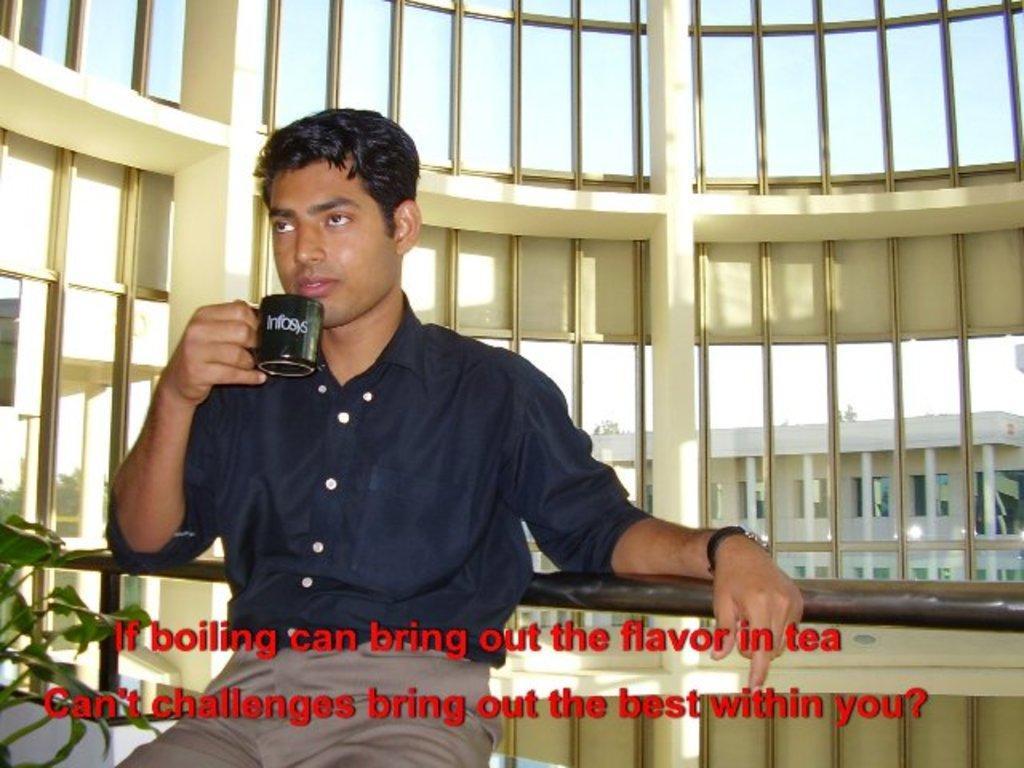Please provide a concise description of this image. In the foreground of the picture we can see a person holding a cup and there are railing, plant and text. In the background we can see a building, wall with glass windows, outside the windows there are trees and building. At the top we can see sky. 